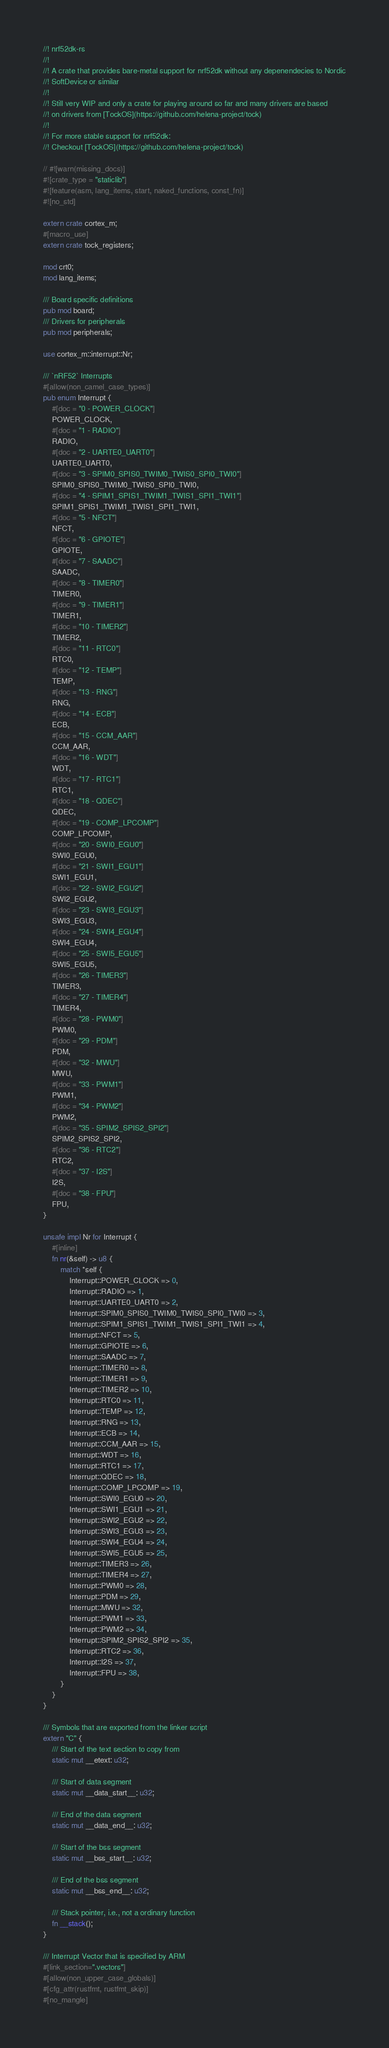Convert code to text. <code><loc_0><loc_0><loc_500><loc_500><_Rust_>//! nrf52dk-rs
//!
//! A crate that provides bare-metal support for nrf52dk without any depenendecies to Nordic
//! SoftDevice or similar
//!
//! Still very WIP and only a crate for playing around so far and many drivers are based
//! on drivers from [TockOS](https://github.com/helena-project/tock)
//!
//! For more stable support for nrf52dk:
//! Checkout [TockOS](https://github.com/helena-project/tock)

// #![warn(missing_docs)]
#![crate_type = "staticlib"]
#![feature(asm, lang_items, start, naked_functions, const_fn)]
#![no_std]

extern crate cortex_m;
#[macro_use]
extern crate tock_registers;

mod crt0;
mod lang_items;

/// Board specific definitions
pub mod board;
/// Drivers for peripherals
pub mod peripherals;

use cortex_m::interrupt::Nr;

/// `nRF52` Interrupts
#[allow(non_camel_case_types)]
pub enum Interrupt {
    #[doc = "0 - POWER_CLOCK"]
    POWER_CLOCK,
    #[doc = "1 - RADIO"]
    RADIO,
    #[doc = "2 - UARTE0_UART0"]
    UARTE0_UART0,
    #[doc = "3 - SPIM0_SPIS0_TWIM0_TWIS0_SPI0_TWI0"]
    SPIM0_SPIS0_TWIM0_TWIS0_SPI0_TWI0,
    #[doc = "4 - SPIM1_SPIS1_TWIM1_TWIS1_SPI1_TWI1"]
    SPIM1_SPIS1_TWIM1_TWIS1_SPI1_TWI1,
    #[doc = "5 - NFCT"]
    NFCT,
    #[doc = "6 - GPIOTE"]
    GPIOTE,
    #[doc = "7 - SAADC"]
    SAADC,
    #[doc = "8 - TIMER0"]
    TIMER0,
    #[doc = "9 - TIMER1"]
    TIMER1,
    #[doc = "10 - TIMER2"]
    TIMER2,
    #[doc = "11 - RTC0"]
    RTC0,
    #[doc = "12 - TEMP"]
    TEMP,
    #[doc = "13 - RNG"]
    RNG,
    #[doc = "14 - ECB"]
    ECB,
    #[doc = "15 - CCM_AAR"]
    CCM_AAR,
    #[doc = "16 - WDT"]
    WDT,
    #[doc = "17 - RTC1"]
    RTC1,
    #[doc = "18 - QDEC"]
    QDEC,
    #[doc = "19 - COMP_LPCOMP"]
    COMP_LPCOMP,
    #[doc = "20 - SWI0_EGU0"]
    SWI0_EGU0,
    #[doc = "21 - SWI1_EGU1"]
    SWI1_EGU1,
    #[doc = "22 - SWI2_EGU2"]
    SWI2_EGU2,
    #[doc = "23 - SWI3_EGU3"]
    SWI3_EGU3,
    #[doc = "24 - SWI4_EGU4"]
    SWI4_EGU4,
    #[doc = "25 - SWI5_EGU5"]
    SWI5_EGU5,
    #[doc = "26 - TIMER3"]
    TIMER3,
    #[doc = "27 - TIMER4"]
    TIMER4,
    #[doc = "28 - PWM0"]
    PWM0,
    #[doc = "29 - PDM"]
    PDM,
    #[doc = "32 - MWU"]
    MWU,
    #[doc = "33 - PWM1"]
    PWM1,
    #[doc = "34 - PWM2"]
    PWM2,
    #[doc = "35 - SPIM2_SPIS2_SPI2"]
    SPIM2_SPIS2_SPI2,
    #[doc = "36 - RTC2"]
    RTC2,
    #[doc = "37 - I2S"]
    I2S,
    #[doc = "38 - FPU"]
    FPU,
}

unsafe impl Nr for Interrupt {
    #[inline]
    fn nr(&self) -> u8 {
        match *self {
            Interrupt::POWER_CLOCK => 0,
            Interrupt::RADIO => 1,
            Interrupt::UARTE0_UART0 => 2,
            Interrupt::SPIM0_SPIS0_TWIM0_TWIS0_SPI0_TWI0 => 3,
            Interrupt::SPIM1_SPIS1_TWIM1_TWIS1_SPI1_TWI1 => 4,
            Interrupt::NFCT => 5,
            Interrupt::GPIOTE => 6,
            Interrupt::SAADC => 7,
            Interrupt::TIMER0 => 8,
            Interrupt::TIMER1 => 9,
            Interrupt::TIMER2 => 10,
            Interrupt::RTC0 => 11,
            Interrupt::TEMP => 12,
            Interrupt::RNG => 13,
            Interrupt::ECB => 14,
            Interrupt::CCM_AAR => 15,
            Interrupt::WDT => 16,
            Interrupt::RTC1 => 17,
            Interrupt::QDEC => 18,
            Interrupt::COMP_LPCOMP => 19,
            Interrupt::SWI0_EGU0 => 20,
            Interrupt::SWI1_EGU1 => 21,
            Interrupt::SWI2_EGU2 => 22,
            Interrupt::SWI3_EGU3 => 23,
            Interrupt::SWI4_EGU4 => 24,
            Interrupt::SWI5_EGU5 => 25,
            Interrupt::TIMER3 => 26,
            Interrupt::TIMER4 => 27,
            Interrupt::PWM0 => 28,
            Interrupt::PDM => 29,
            Interrupt::MWU => 32,
            Interrupt::PWM1 => 33,
            Interrupt::PWM2 => 34,
            Interrupt::SPIM2_SPIS2_SPI2 => 35,
            Interrupt::RTC2 => 36,
            Interrupt::I2S => 37,
            Interrupt::FPU => 38,
        }
    }
}

/// Symbols that are exported from the linker script
extern "C" {
    /// Start of the text section to copy from
    static mut __etext: u32;

    /// Start of data segment
    static mut __data_start__: u32;

    /// End of the data segment
    static mut __data_end__: u32;

    /// Start of the bss segment
    static mut __bss_start__: u32;

    /// End of the bss segment
    static mut __bss_end__: u32;

    /// Stack pointer, i.e., not a ordinary function
    fn __stack();
}

/// Interrupt Vector that is specified by ARM
#[link_section=".vectors"]
#[allow(non_upper_case_globals)]
#[cfg_attr(rustfmt, rustfmt_skip)]
#[no_mangle]</code> 